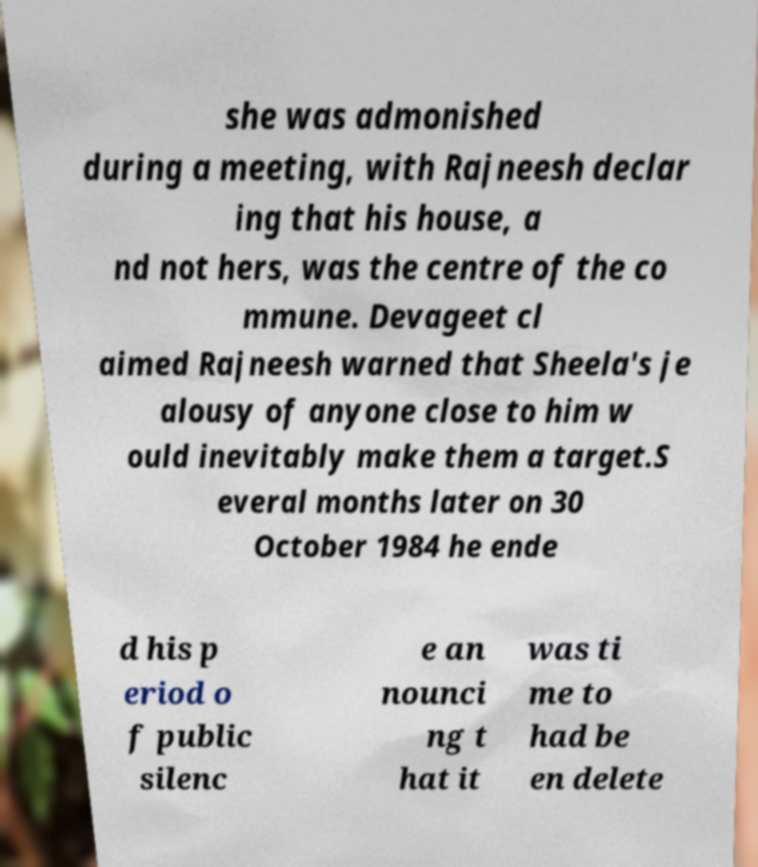There's text embedded in this image that I need extracted. Can you transcribe it verbatim? she was admonished during a meeting, with Rajneesh declar ing that his house, a nd not hers, was the centre of the co mmune. Devageet cl aimed Rajneesh warned that Sheela's je alousy of anyone close to him w ould inevitably make them a target.S everal months later on 30 October 1984 he ende d his p eriod o f public silenc e an nounci ng t hat it was ti me to had be en delete 